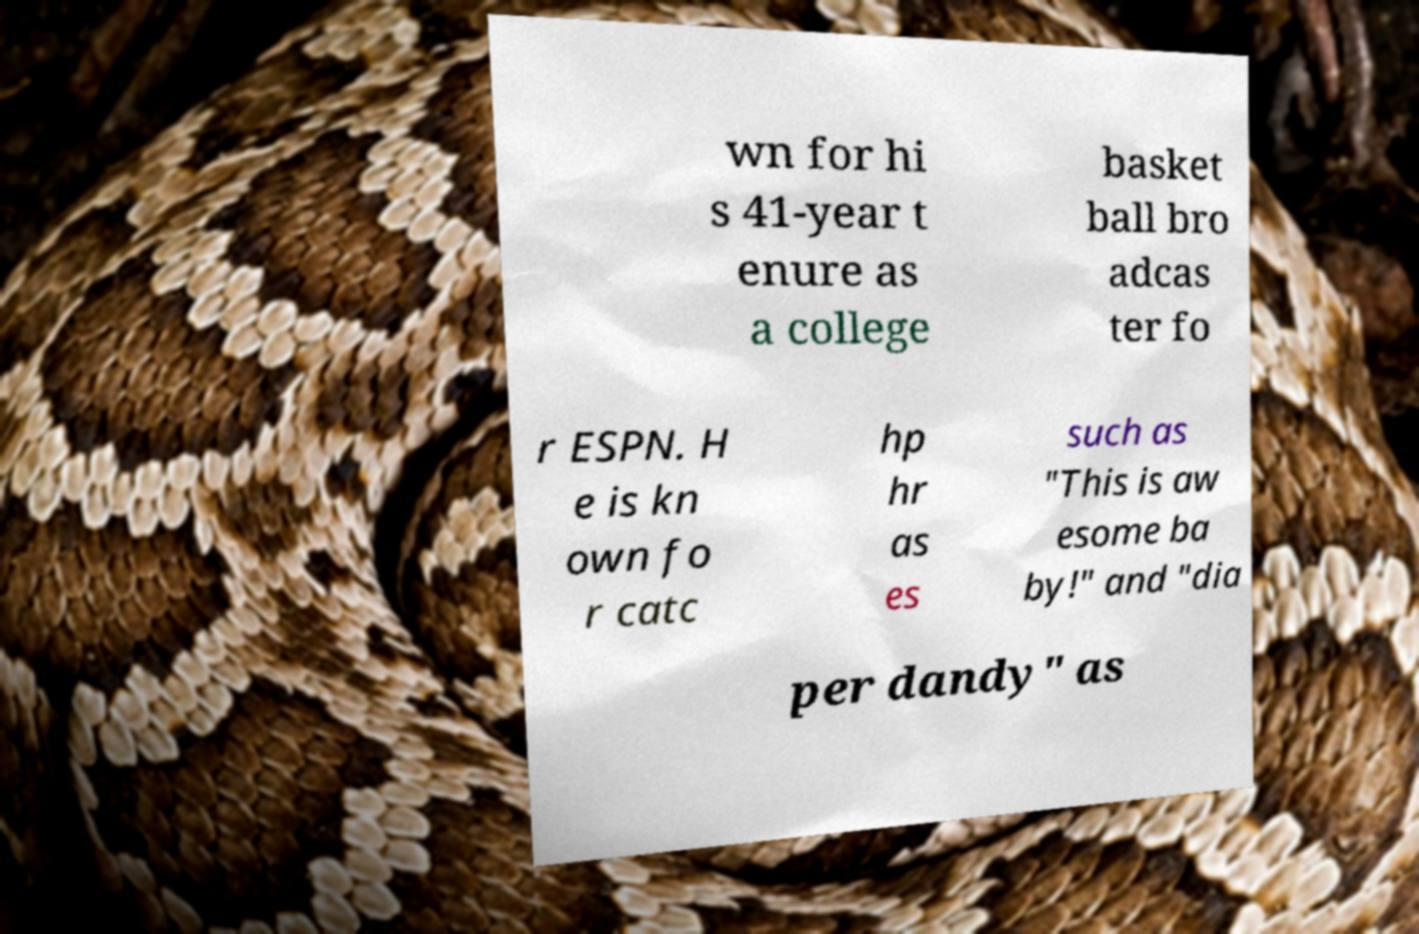Please identify and transcribe the text found in this image. wn for hi s 41-year t enure as a college basket ball bro adcas ter fo r ESPN. H e is kn own fo r catc hp hr as es such as "This is aw esome ba by!" and "dia per dandy" as 